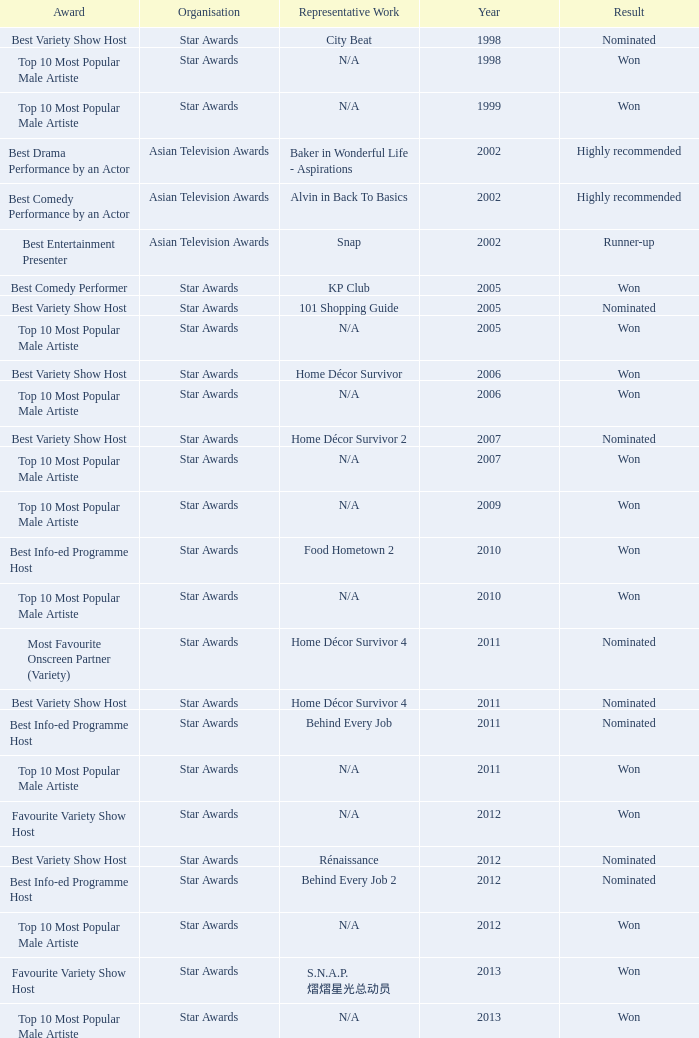What is the name of the Representative Work in a year later than 2005 with a Result of nominated, and an Award of best variety show host? Home Décor Survivor 2, Home Décor Survivor 4, Rénaissance, Jobs Around The World. 